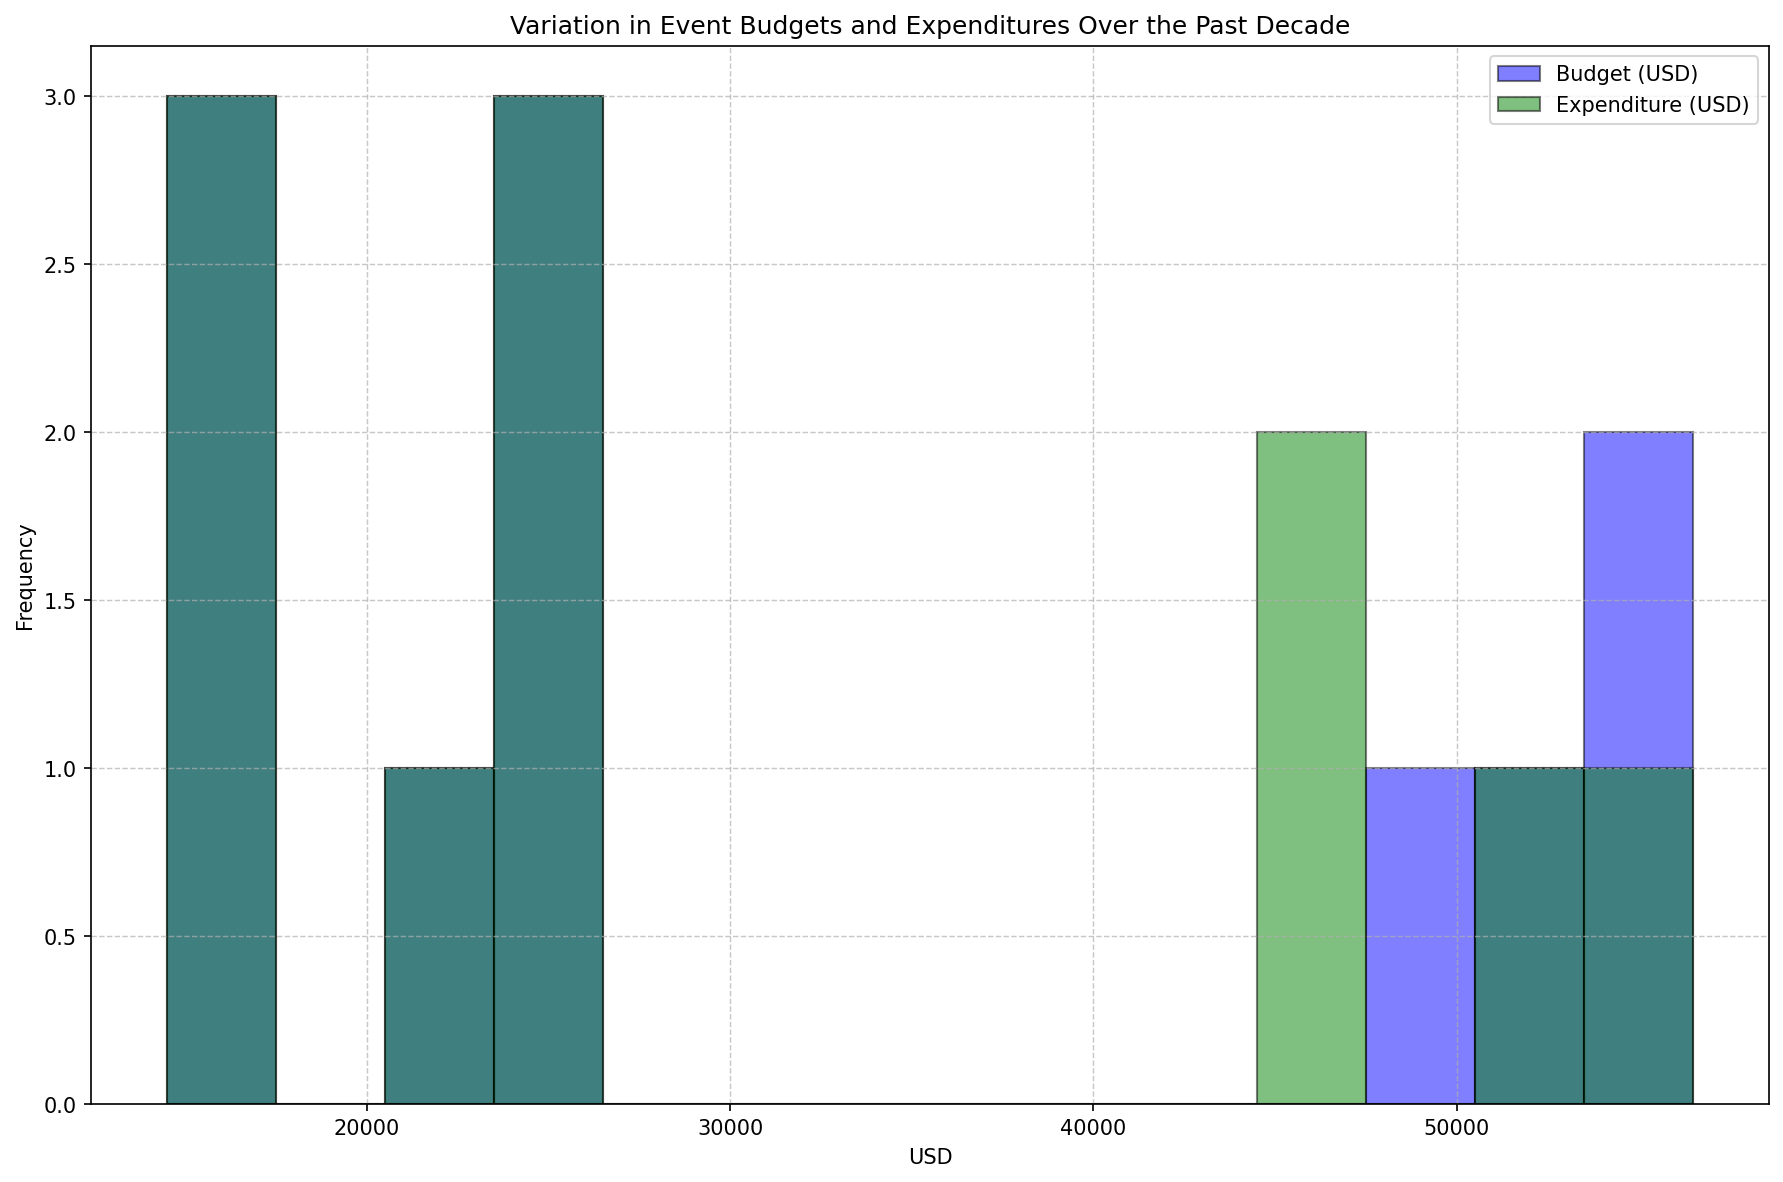What's the average Budget for the events over the decade? To calculate the average Budget, sum the Budget values for all years and divide by the number of years. The sum of Budgets is 15,000 + 80,000 + 25,000 + 20,000 + 12,000 + 18,000 + 16,000 + 85,000 + 26,000 + 22,000 + 12,500 + 18,500 + 17,000 + 90,000 + 27,000 + 23,000 + 13,000 + 19,000 + 18,000 + 95,000 + 28,000 + 24,000, which totals 764,000. Dividing by 11 years, the average Budget is approximately 34,727 USD.
Answer: 34,727 USD What's the highest frequency range for the Budgets? Observing the Budget histogram, the highest bar indicates the most frequent Budget range. If the bar in the 25,000 - 40,000 range is tallest, this range appears the most frequently. By counting the visual bars, the maximum frequency is within the 25,000 - 40,000 USD range.
Answer: 25,000 - 40,000 USD Does any Expenditure range have a higher frequency than any Budget range? Compare the highest bars of each histogram. If the tallest bar of the Expenditure histogram is higher than any bar of the Budget histogram, then yes. Visually observing both histograms' heights, if the Expenditure's bar surpasses the highest Budget bar, it confirms.
Answer: No Which has a greater spread, Budget or Expenditure? Spread refers to the range of values a dataset covers. This can be measured by comparing the range (max - min) of both histograms. Calculate the range of Budget as (95,000 - 12,000) = 83,000 and Expenditure as (93,000 - 11,500) = 81,500. Visually, by determining the width of the histograms, the Budget histogram covers a wider range hinting at a greater spread.
Answer: Budget In which range do Budgets and Expenditures most overlap? Look for the histogram regions where Budget (blue) and Expenditure (green) bars align and both have significant heights. If the highest overlaps are observed between 60,000 - 80,000 USD, that’s the overlapping range. Visually, overlapping bars are high within a clear range.
Answer: 25,000 - 40,000 USD Are there more years with Budgets greater than 40,000 USD or Expenditures greater than 40,000 USD? Count the years in the histogram where bars for Budget exceed 40,000 and compare with the count of Expenditure bars exceeding 40,000. If Budgets have fewer high bars beyond the 40,000 bins compared to Expenditures, there’s a visual confirmation.
Answer: Budgets Does the frequency of Expenditures in the 15,000 - 25,000 USD range exceed those of Budgets? Examine two specific bars within the histogram in the 15,000 - 25,000 bin ranges for both Budget (blue) and Expenditure (green). Counting and comparing these bar heights should indicate that Expenditure in this range is lower or equal.
Answer: No What's the budget range with the lowest frequency of events? Identify the shortest bar in the Budget histogram. If the shortest bar falls in the 80,000 - 95,000 range, it indicates the least event within this monetary limit. Visually, compare and identify the least tall Budget histogram bar.
Answer: 80,000 - 95,000 USD Which has a more consistent distribution, Budgets or Expenditures? Consistent distribution implies less fluctuation across bins. Observe both histograms, the histogram with bars closer to equal heights represents the more consistent distribution. If Expenditure histogram bars are more uniform, it indicates higher consistency compared to Budget.
Answer: Expenditures 